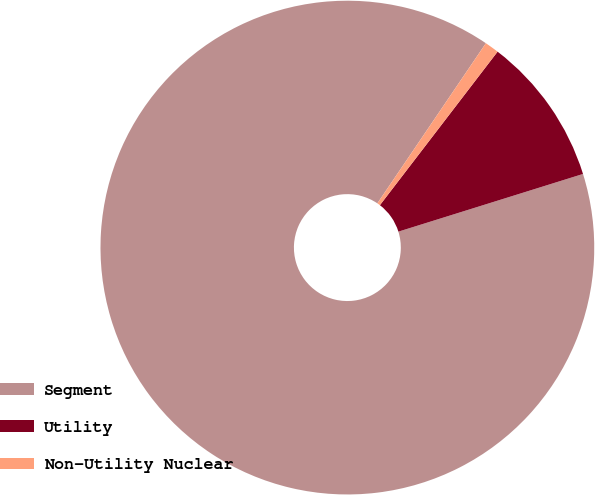<chart> <loc_0><loc_0><loc_500><loc_500><pie_chart><fcel>Segment<fcel>Utility<fcel>Non-Utility Nuclear<nl><fcel>89.3%<fcel>9.77%<fcel>0.93%<nl></chart> 